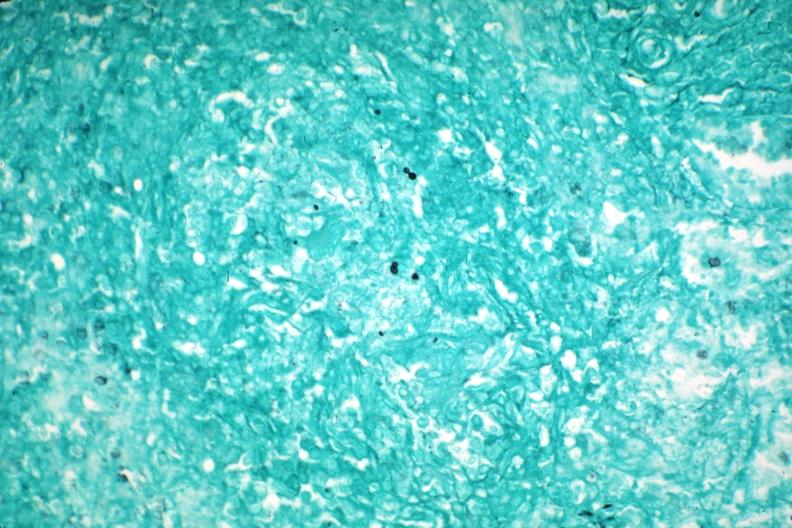s hematologic present?
Answer the question using a single word or phrase. Yes 